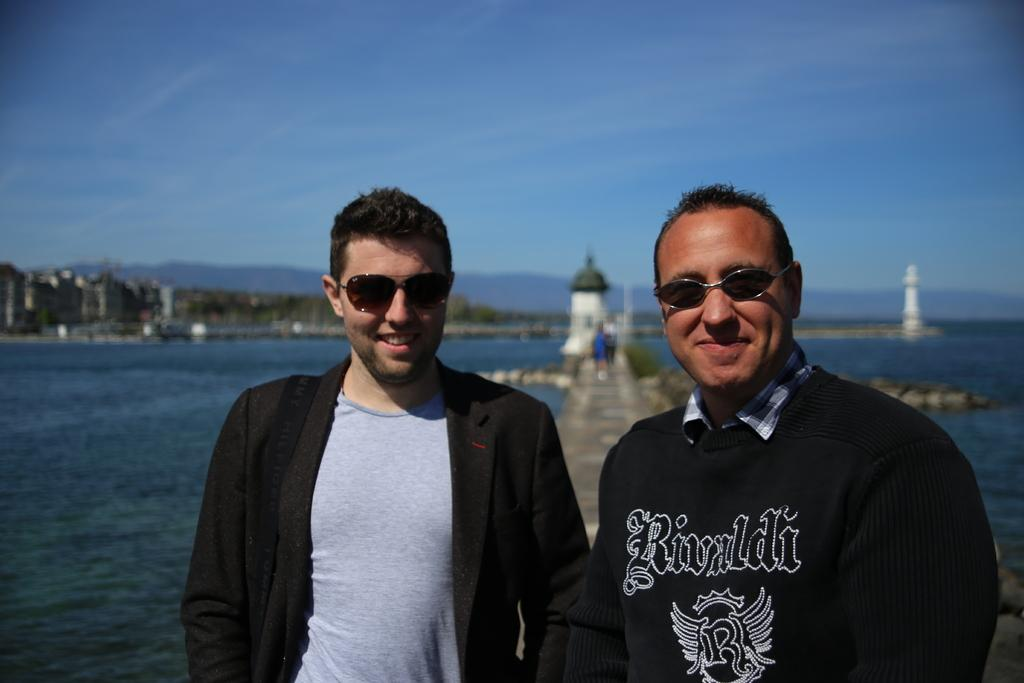How many people are in the image? There are two men standing in the image. What are the men wearing that is common to both of them? Both men are wearing glasses. What can be seen in the background of the image? There is water, towers, and the sky visible in the background of the image. What type of grape is being harvested at the plantation in the image? There is no plantation or grapes present in the image; it features two men wearing glasses and the background elements mentioned earlier. 